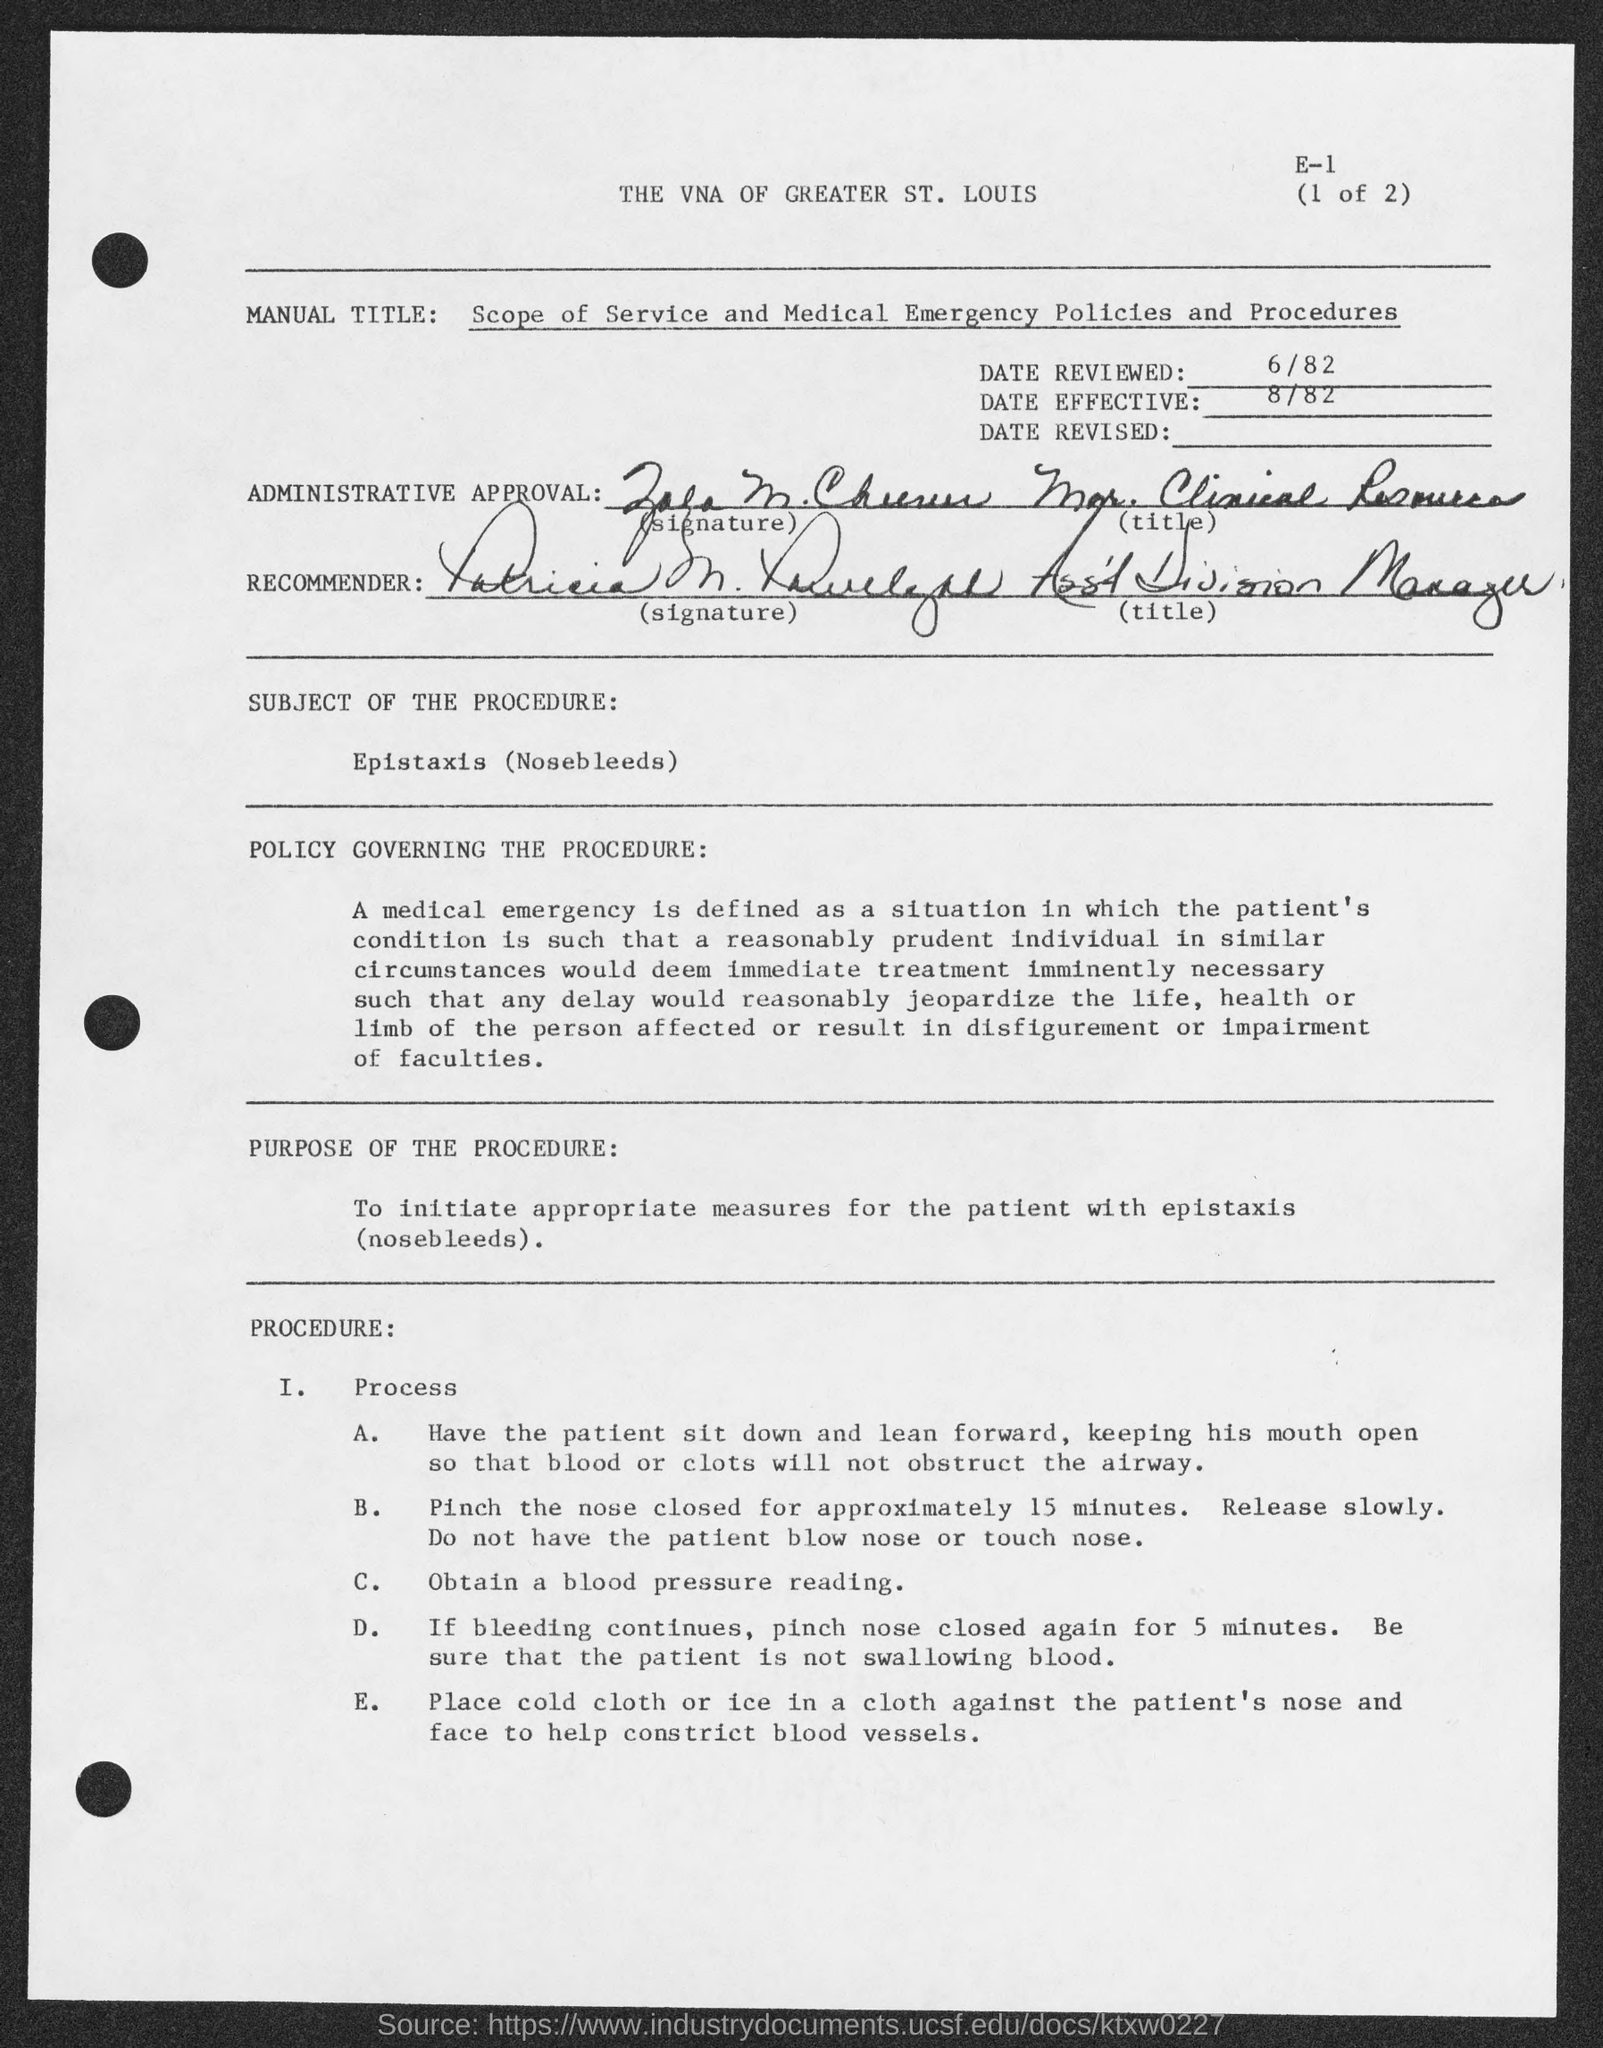What is the procedure called?
Keep it short and to the point. Epistaxis. When is this effective from?
Your answer should be compact. 8/82. How much time nose must be pinched?
Offer a terse response. 15 minutes. What is the title of Recommender?
Your answer should be compact. Asst Division Manager. 